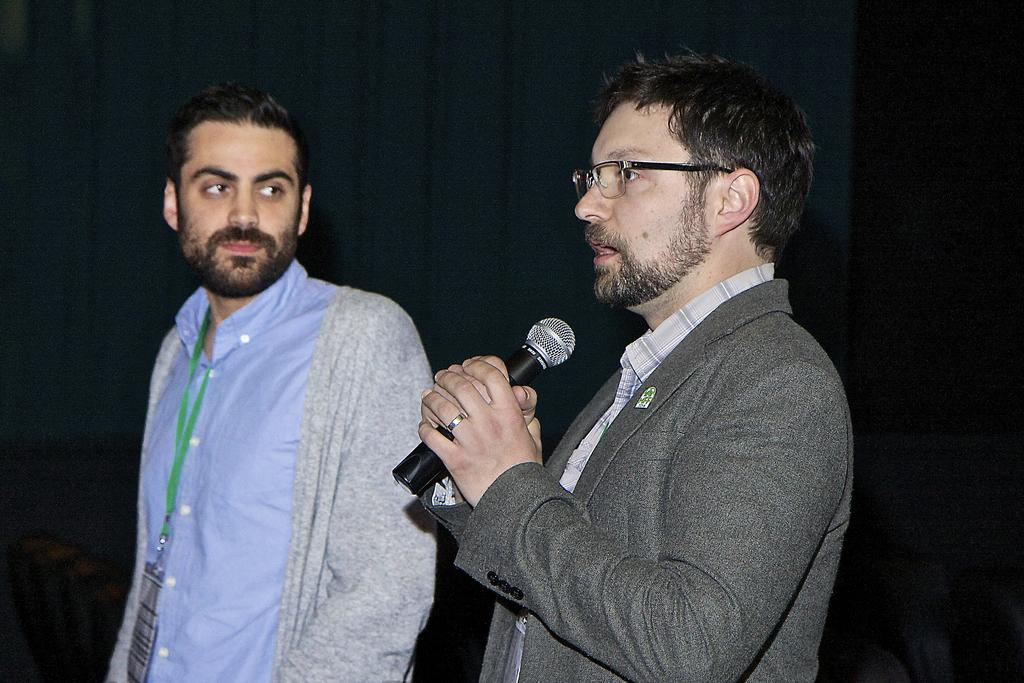How many people are in the image? There are two men in the image. What is one of the men holding? One of the men is holding a microphone. Can you describe the appearance of the man holding the microphone? The man holding the microphone is wearing glasses. What type of wren can be seen perched on the microphone in the image? There is no wren present in the image; it features two men, one of whom is holding a microphone. How does the man holding the microphone grip it in the image? The image does not provide information about how the man is gripping the microphone, only that he is holding it. 